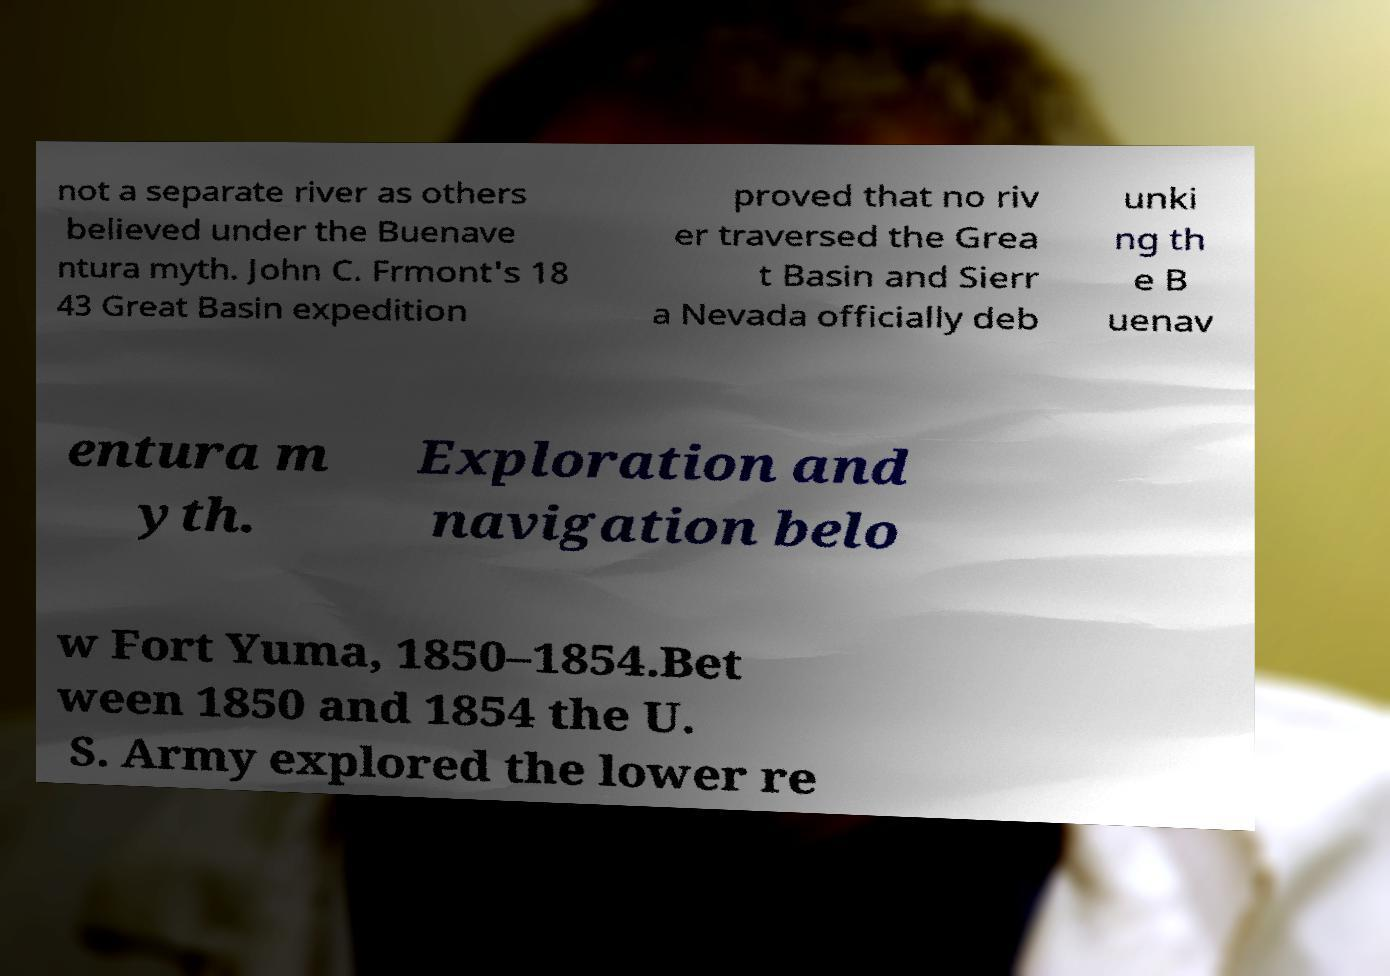Could you extract and type out the text from this image? not a separate river as others believed under the Buenave ntura myth. John C. Frmont's 18 43 Great Basin expedition proved that no riv er traversed the Grea t Basin and Sierr a Nevada officially deb unki ng th e B uenav entura m yth. Exploration and navigation belo w Fort Yuma, 1850–1854.Bet ween 1850 and 1854 the U. S. Army explored the lower re 